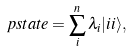<formula> <loc_0><loc_0><loc_500><loc_500>\ p s t a t e = \sum _ { i } ^ { n } \lambda _ { i } | i i \rangle ,</formula> 